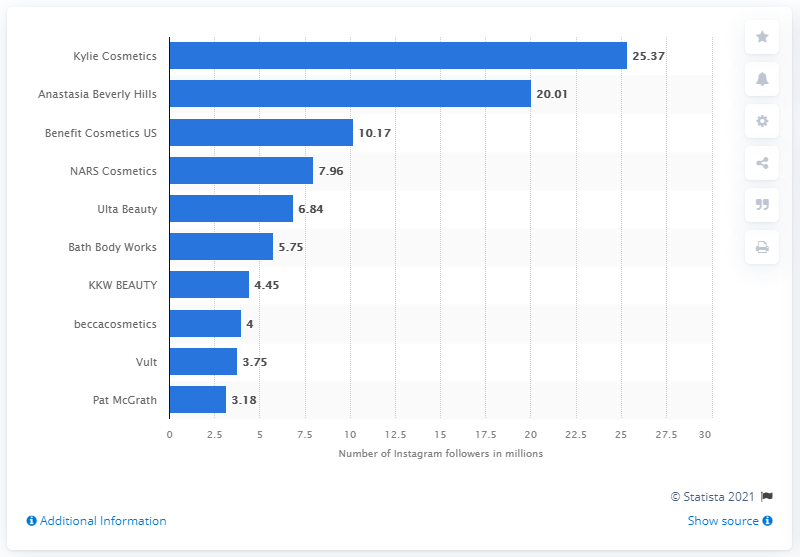Mention a couple of crucial points in this snapshot. As of June 2021, Kylie Cosmetics was the most popular beauty brand on Instagram. Anastasia Beverly Hills was the second most popular beauty brand on Instagram in June 2021. 